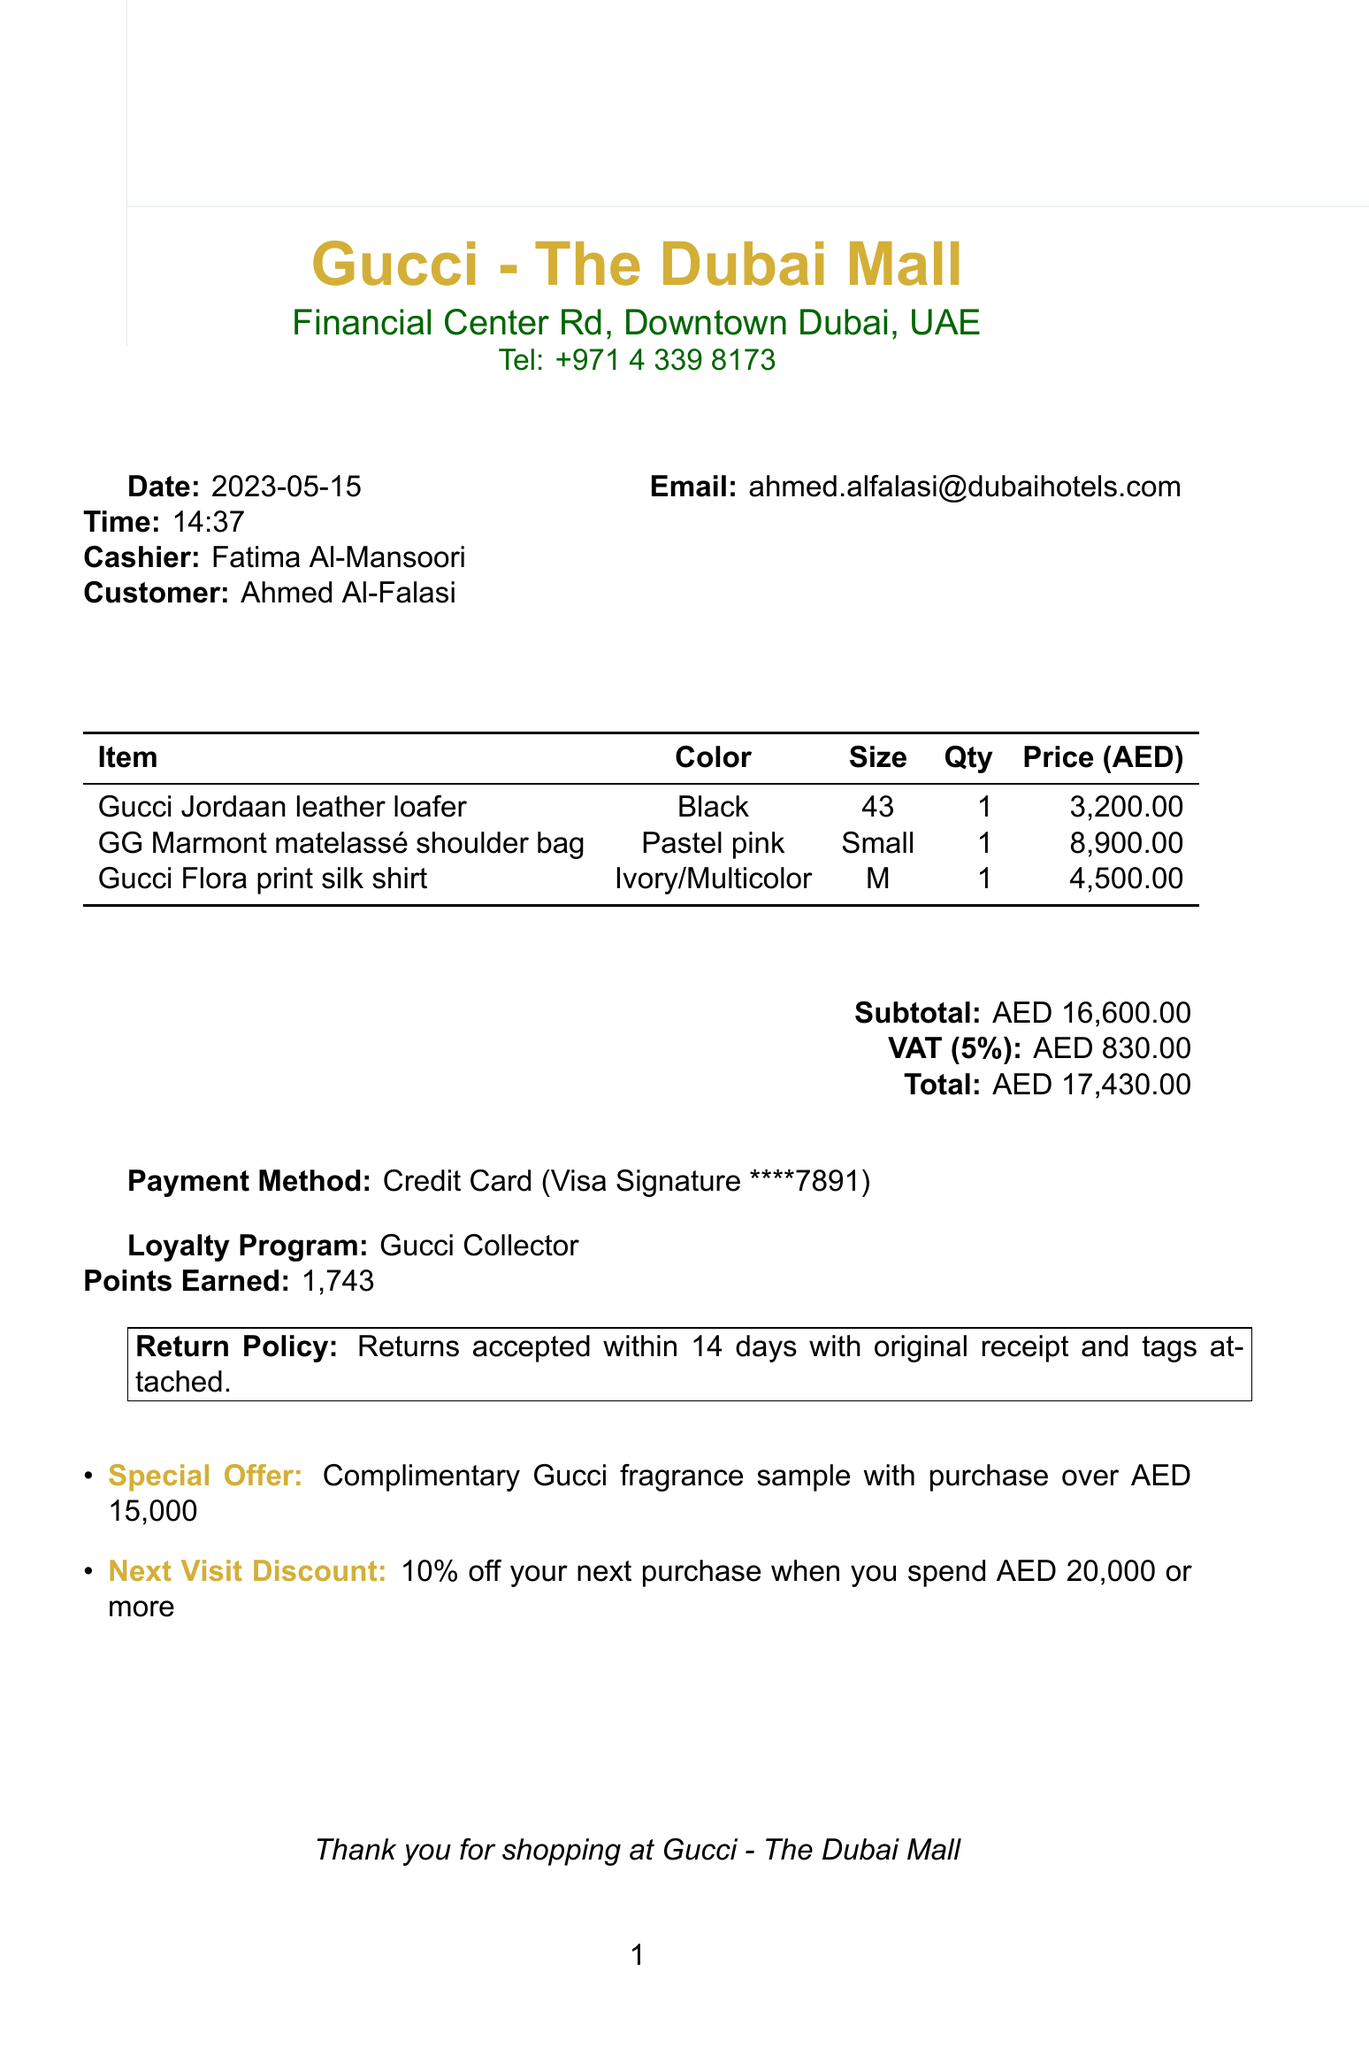What is the store name? The store name is listed at the top of the document.
Answer: Gucci - The Dubai Mall What is the subtotal amount? The subtotal is the sum of item prices before VAT is added.
Answer: AED 16,600.00 Who was the cashier? The cashier's name is provided in the document under the cashier section.
Answer: Fatima Al-Mansoori What is the total amount after VAT? The total includes the subtotal and VAT.
Answer: AED 17,430.00 What date was the purchase made? The date is mentioned prominently in the document.
Answer: 2023-05-15 How many points did the customer earn? Points earned are specified in the loyalty program section of the document.
Answer: 1,743 What are the return policy details? The return policy is summarized in a boxed section of the document.
Answer: Returns accepted within 14 days with original receipt and tags attached What is the special offer provided? The special offer is noted in the itemized list at the end.
Answer: Complimentary Gucci fragrance sample with purchase over AED 15,000 What is the customer’s email address? The email is listed under the customer information section.
Answer: ahmed.alfalasi@dubaihotels.com How many items were purchased? The number of items is indicated by the number of entries in the itemized list.
Answer: 3 